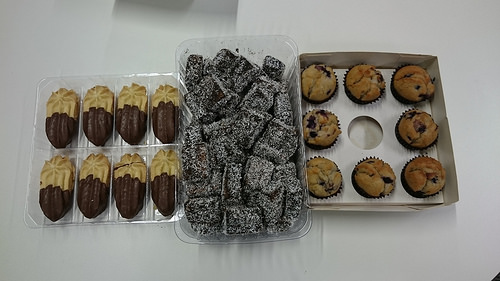<image>
Is the muffin next to the cookie? No. The muffin is not positioned next to the cookie. They are located in different areas of the scene. 